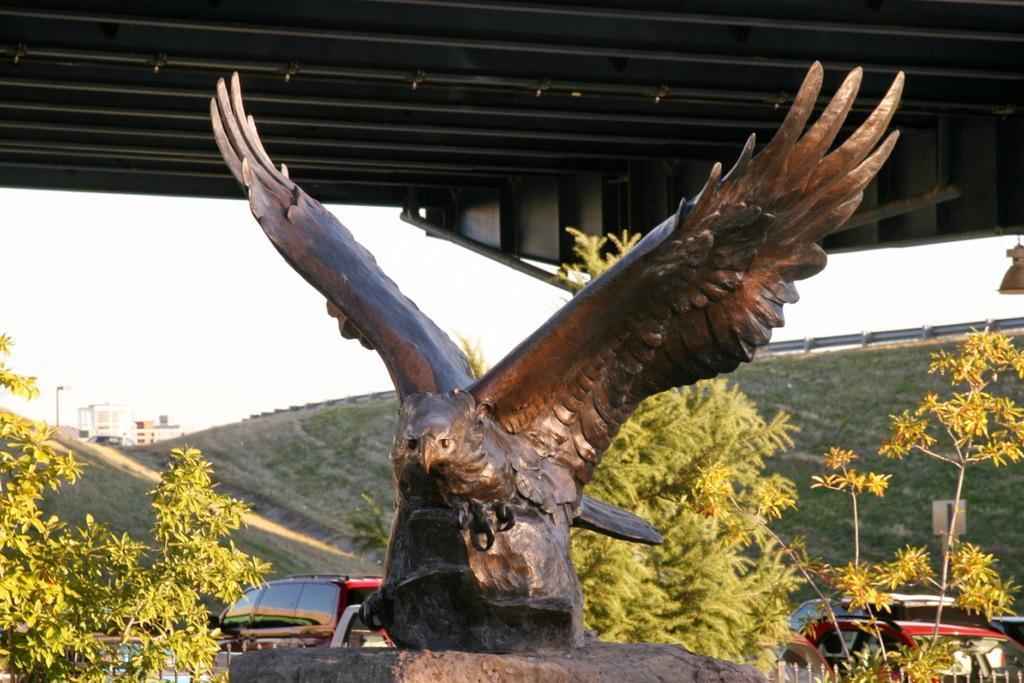Describe this image in one or two sentences. Under the shed there is a statue. In the background of the image there are trees, grass, buildings, light pole, vehicles, board and sky. 